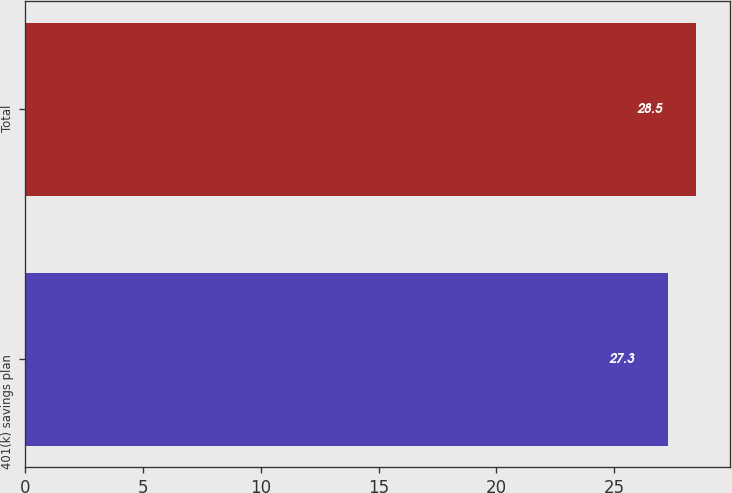Convert chart. <chart><loc_0><loc_0><loc_500><loc_500><bar_chart><fcel>401(k) savings plan<fcel>Total<nl><fcel>27.3<fcel>28.5<nl></chart> 